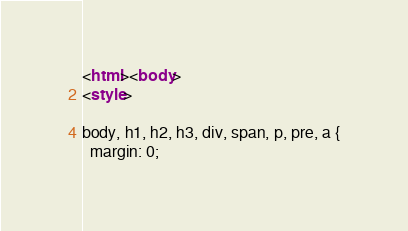<code> <loc_0><loc_0><loc_500><loc_500><_HTML_><html><body>
<style>

body, h1, h2, h3, div, span, p, pre, a {
  margin: 0;</code> 